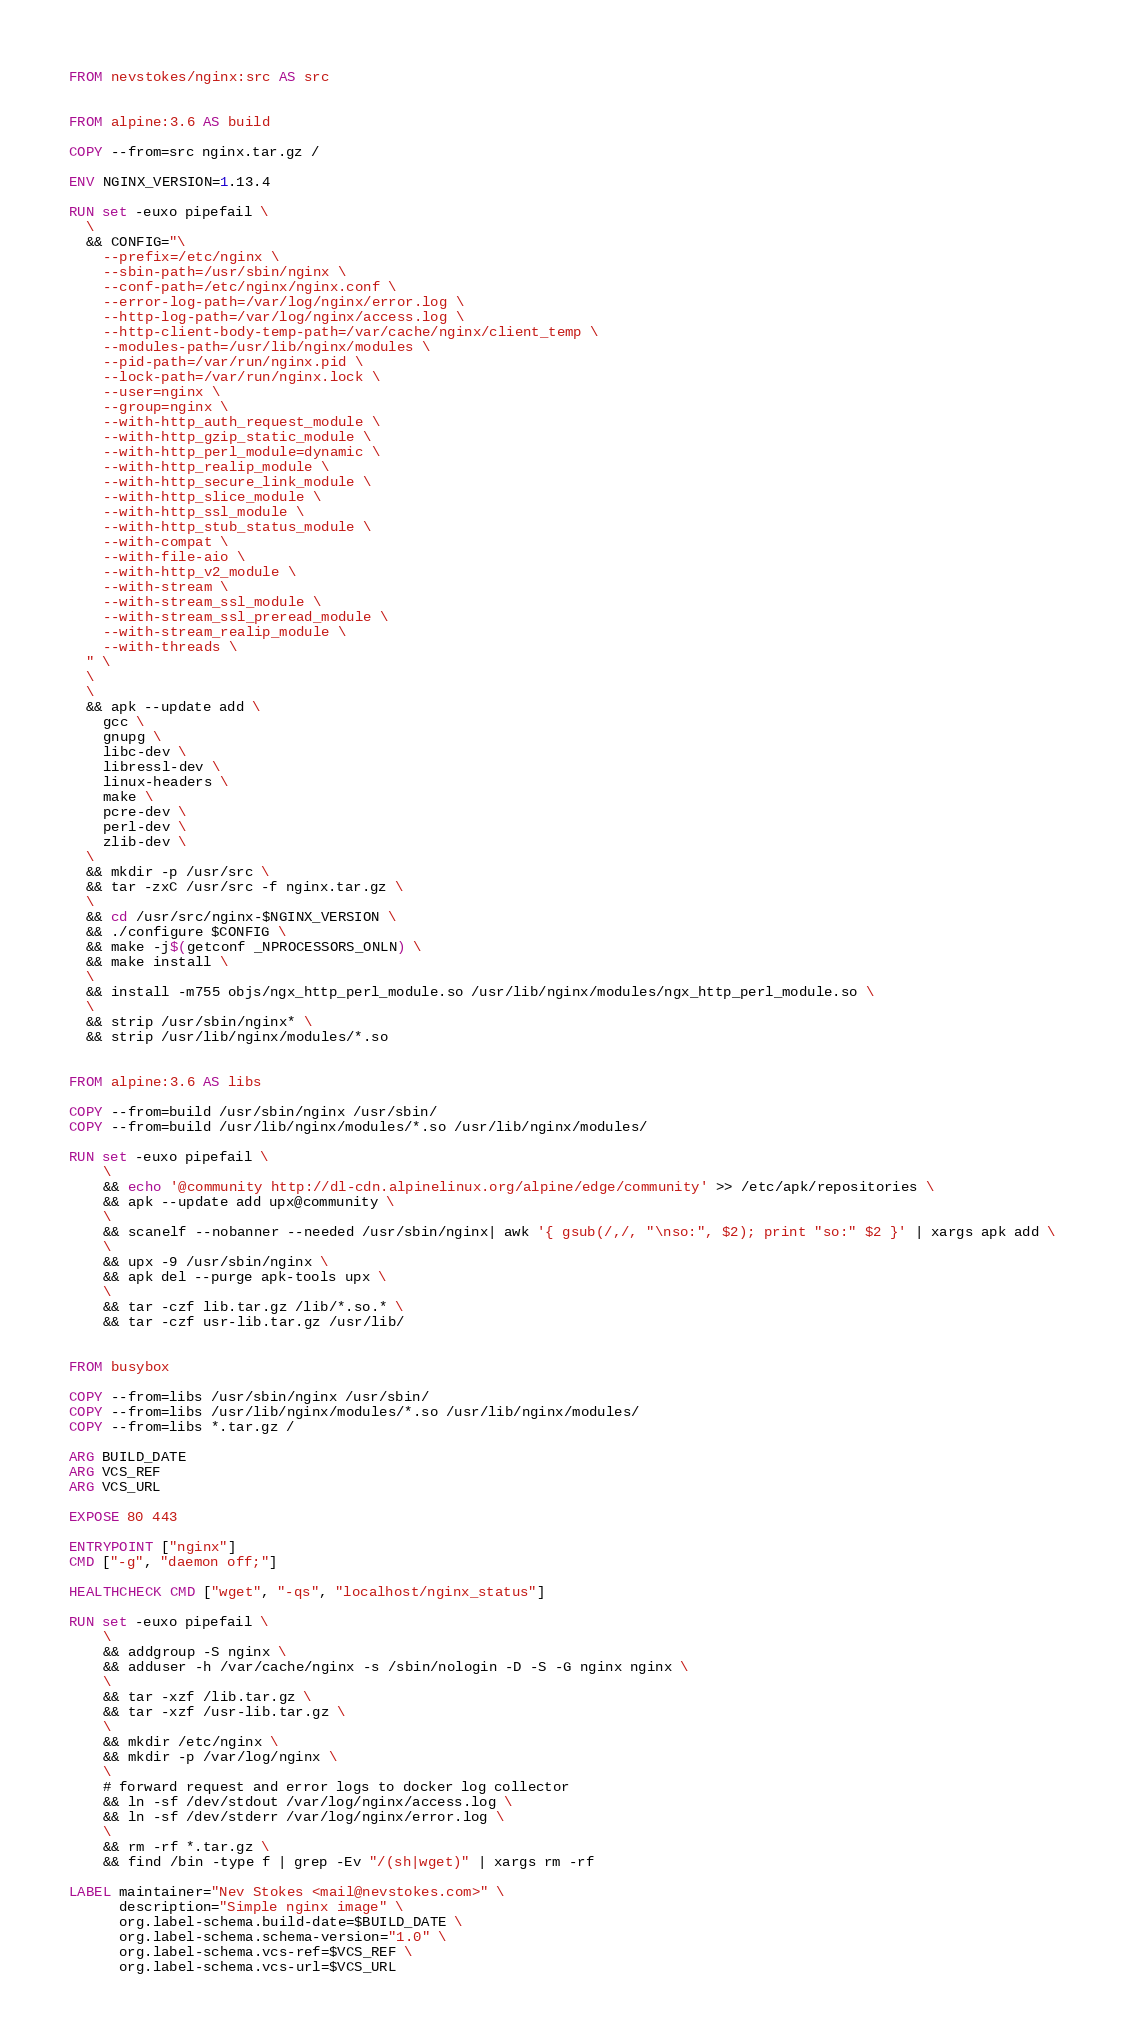Convert code to text. <code><loc_0><loc_0><loc_500><loc_500><_Dockerfile_>FROM nevstokes/nginx:src AS src


FROM alpine:3.6 AS build

COPY --from=src nginx.tar.gz /

ENV NGINX_VERSION=1.13.4

RUN set -euxo pipefail \
  \
  && CONFIG="\
    --prefix=/etc/nginx \
    --sbin-path=/usr/sbin/nginx \
    --conf-path=/etc/nginx/nginx.conf \
    --error-log-path=/var/log/nginx/error.log \
    --http-log-path=/var/log/nginx/access.log \
    --http-client-body-temp-path=/var/cache/nginx/client_temp \
    --modules-path=/usr/lib/nginx/modules \
    --pid-path=/var/run/nginx.pid \
    --lock-path=/var/run/nginx.lock \
    --user=nginx \
    --group=nginx \
    --with-http_auth_request_module \
    --with-http_gzip_static_module \
    --with-http_perl_module=dynamic \
    --with-http_realip_module \
    --with-http_secure_link_module \
    --with-http_slice_module \
    --with-http_ssl_module \
    --with-http_stub_status_module \
    --with-compat \
    --with-file-aio \
    --with-http_v2_module \
    --with-stream \
    --with-stream_ssl_module \
    --with-stream_ssl_preread_module \
    --with-stream_realip_module \
    --with-threads \
  " \
  \
  \
  && apk --update add \
    gcc \
    gnupg \
    libc-dev \
    libressl-dev \
    linux-headers \
    make \
    pcre-dev \
    perl-dev \
    zlib-dev \
  \
  && mkdir -p /usr/src \
  && tar -zxC /usr/src -f nginx.tar.gz \
  \
  && cd /usr/src/nginx-$NGINX_VERSION \
  && ./configure $CONFIG \
  && make -j$(getconf _NPROCESSORS_ONLN) \
  && make install \
  \
  && install -m755 objs/ngx_http_perl_module.so /usr/lib/nginx/modules/ngx_http_perl_module.so \
  \
  && strip /usr/sbin/nginx* \
  && strip /usr/lib/nginx/modules/*.so


FROM alpine:3.6 AS libs

COPY --from=build /usr/sbin/nginx /usr/sbin/
COPY --from=build /usr/lib/nginx/modules/*.so /usr/lib/nginx/modules/

RUN set -euxo pipefail \
    \
    && echo '@community http://dl-cdn.alpinelinux.org/alpine/edge/community' >> /etc/apk/repositories \
    && apk --update add upx@community \
    \
    && scanelf --nobanner --needed /usr/sbin/nginx| awk '{ gsub(/,/, "\nso:", $2); print "so:" $2 }' | xargs apk add \
    \
    && upx -9 /usr/sbin/nginx \
    && apk del --purge apk-tools upx \
    \
    && tar -czf lib.tar.gz /lib/*.so.* \
    && tar -czf usr-lib.tar.gz /usr/lib/


FROM busybox

COPY --from=libs /usr/sbin/nginx /usr/sbin/
COPY --from=libs /usr/lib/nginx/modules/*.so /usr/lib/nginx/modules/
COPY --from=libs *.tar.gz /

ARG BUILD_DATE
ARG VCS_REF
ARG VCS_URL

EXPOSE 80 443

ENTRYPOINT ["nginx"]
CMD ["-g", "daemon off;"]

HEALTHCHECK CMD ["wget", "-qs", "localhost/nginx_status"]

RUN set -euxo pipefail \
    \
    && addgroup -S nginx \
    && adduser -h /var/cache/nginx -s /sbin/nologin -D -S -G nginx nginx \
    \
    && tar -xzf /lib.tar.gz \
    && tar -xzf /usr-lib.tar.gz \
    \
    && mkdir /etc/nginx \
    && mkdir -p /var/log/nginx \
    \
    # forward request and error logs to docker log collector
    && ln -sf /dev/stdout /var/log/nginx/access.log \
    && ln -sf /dev/stderr /var/log/nginx/error.log \
    \
    && rm -rf *.tar.gz \
    && find /bin -type f | grep -Ev "/(sh|wget)" | xargs rm -rf

LABEL maintainer="Nev Stokes <mail@nevstokes.com>" \
      description="Simple nginx image" \
      org.label-schema.build-date=$BUILD_DATE \
      org.label-schema.schema-version="1.0" \
      org.label-schema.vcs-ref=$VCS_REF \
      org.label-schema.vcs-url=$VCS_URL
</code> 